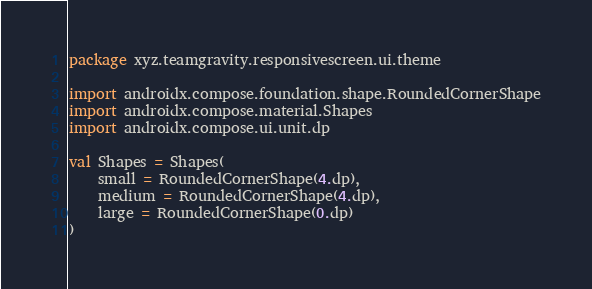Convert code to text. <code><loc_0><loc_0><loc_500><loc_500><_Kotlin_>package xyz.teamgravity.responsivescreen.ui.theme

import androidx.compose.foundation.shape.RoundedCornerShape
import androidx.compose.material.Shapes
import androidx.compose.ui.unit.dp

val Shapes = Shapes(
    small = RoundedCornerShape(4.dp),
    medium = RoundedCornerShape(4.dp),
    large = RoundedCornerShape(0.dp)
)</code> 